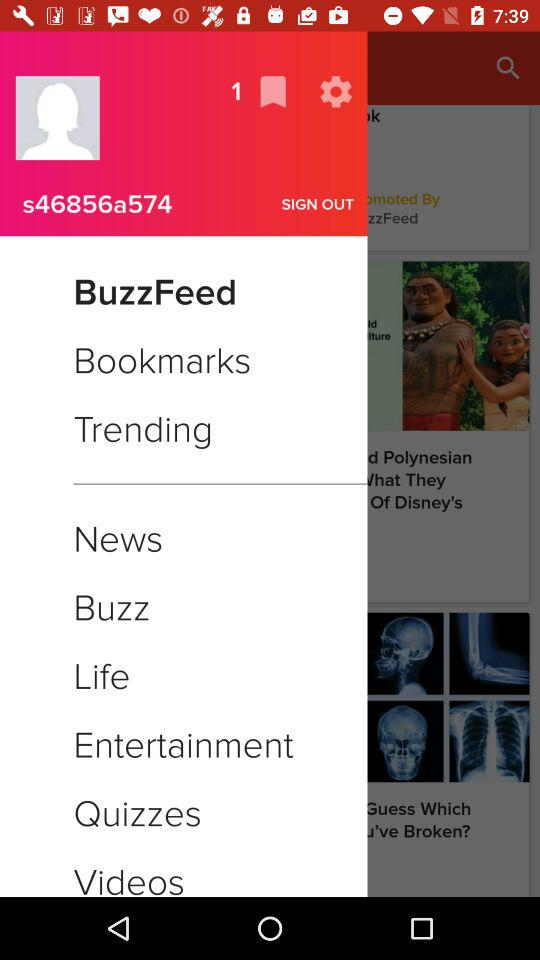What is the user name? The username is "s46856a574". 